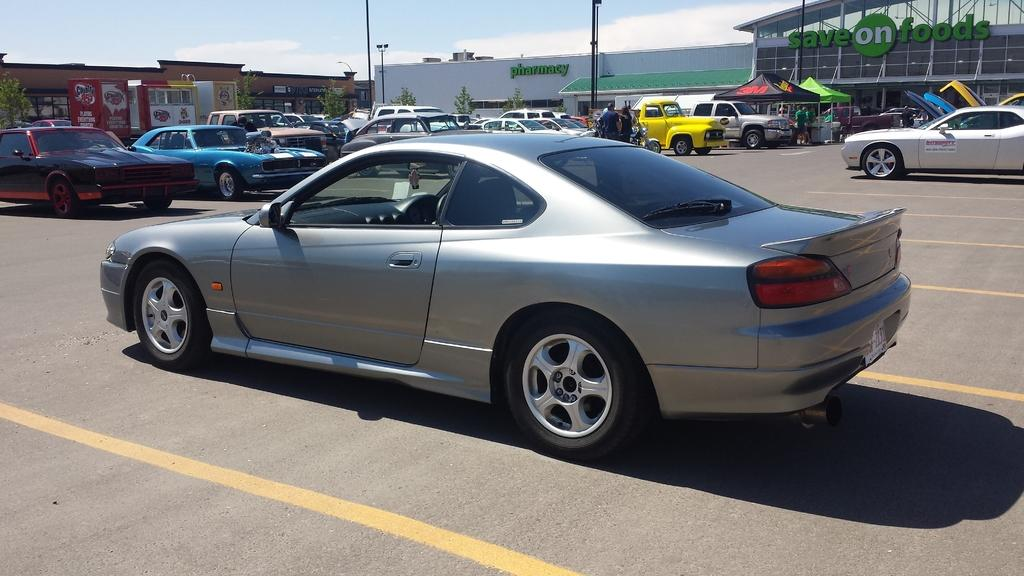What can be seen on the road in the image? There are vehicles on the road in the image. What is visible in the background of the image? There are different stores visible in the background of the image. What are the people doing in the background of the image? People are standing outside the stores in the background of the image. Can you see a receipt for the lumber purchase in the image? There is no mention of lumber or a receipt in the image; it features vehicles on the road and stores in the background. 